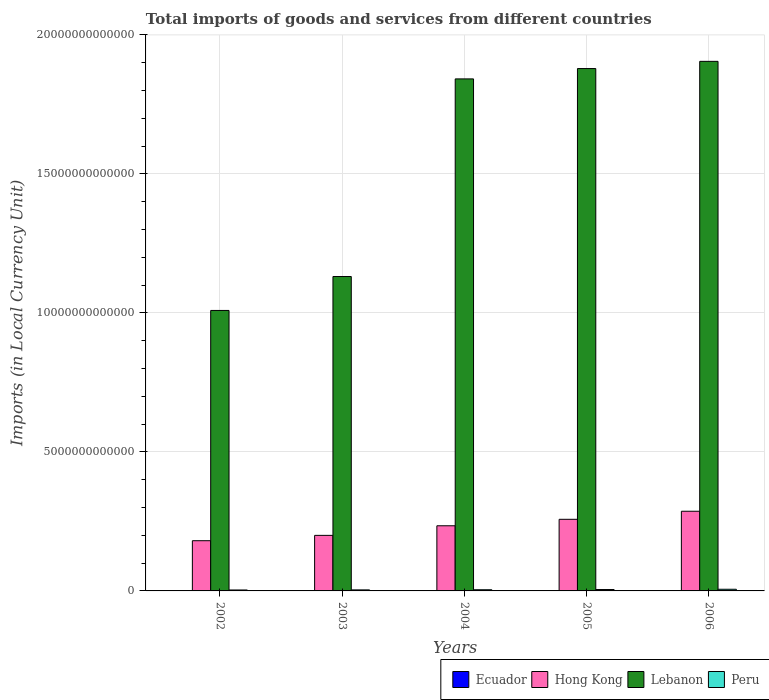Are the number of bars per tick equal to the number of legend labels?
Offer a terse response. Yes. Are the number of bars on each tick of the X-axis equal?
Make the answer very short. Yes. How many bars are there on the 5th tick from the right?
Your answer should be compact. 4. What is the label of the 5th group of bars from the left?
Make the answer very short. 2006. What is the Amount of goods and services imports in Ecuador in 2005?
Keep it short and to the point. 1.18e+1. Across all years, what is the maximum Amount of goods and services imports in Peru?
Offer a very short reply. 6.00e+1. Across all years, what is the minimum Amount of goods and services imports in Hong Kong?
Offer a very short reply. 1.81e+12. In which year was the Amount of goods and services imports in Lebanon maximum?
Your answer should be compact. 2006. In which year was the Amount of goods and services imports in Ecuador minimum?
Offer a very short reply. 2002. What is the total Amount of goods and services imports in Ecuador in the graph?
Offer a very short reply. 5.11e+1. What is the difference between the Amount of goods and services imports in Peru in 2003 and that in 2006?
Make the answer very short. -2.28e+1. What is the difference between the Amount of goods and services imports in Hong Kong in 2005 and the Amount of goods and services imports in Ecuador in 2006?
Your answer should be compact. 2.56e+12. What is the average Amount of goods and services imports in Peru per year?
Offer a terse response. 4.48e+1. In the year 2006, what is the difference between the Amount of goods and services imports in Peru and Amount of goods and services imports in Lebanon?
Provide a short and direct response. -1.90e+13. In how many years, is the Amount of goods and services imports in Lebanon greater than 4000000000000 LCU?
Offer a very short reply. 5. What is the ratio of the Amount of goods and services imports in Peru in 2004 to that in 2006?
Your response must be concise. 0.71. Is the Amount of goods and services imports in Ecuador in 2003 less than that in 2004?
Provide a succinct answer. Yes. Is the difference between the Amount of goods and services imports in Peru in 2004 and 2005 greater than the difference between the Amount of goods and services imports in Lebanon in 2004 and 2005?
Ensure brevity in your answer.  Yes. What is the difference between the highest and the second highest Amount of goods and services imports in Lebanon?
Offer a terse response. 2.59e+11. What is the difference between the highest and the lowest Amount of goods and services imports in Ecuador?
Your answer should be very brief. 5.79e+09. Is the sum of the Amount of goods and services imports in Hong Kong in 2004 and 2005 greater than the maximum Amount of goods and services imports in Lebanon across all years?
Offer a terse response. No. Is it the case that in every year, the sum of the Amount of goods and services imports in Peru and Amount of goods and services imports in Hong Kong is greater than the sum of Amount of goods and services imports in Lebanon and Amount of goods and services imports in Ecuador?
Keep it short and to the point. No. What does the 1st bar from the left in 2006 represents?
Your response must be concise. Ecuador. What does the 2nd bar from the right in 2002 represents?
Ensure brevity in your answer.  Lebanon. How many bars are there?
Give a very brief answer. 20. How many years are there in the graph?
Your response must be concise. 5. What is the difference between two consecutive major ticks on the Y-axis?
Ensure brevity in your answer.  5.00e+12. Are the values on the major ticks of Y-axis written in scientific E-notation?
Your response must be concise. No. Does the graph contain grids?
Make the answer very short. Yes. Where does the legend appear in the graph?
Make the answer very short. Bottom right. What is the title of the graph?
Ensure brevity in your answer.  Total imports of goods and services from different countries. Does "Northern Mariana Islands" appear as one of the legend labels in the graph?
Offer a very short reply. No. What is the label or title of the Y-axis?
Give a very brief answer. Imports (in Local Currency Unit). What is the Imports (in Local Currency Unit) in Ecuador in 2002?
Offer a very short reply. 7.96e+09. What is the Imports (in Local Currency Unit) of Hong Kong in 2002?
Provide a succinct answer. 1.81e+12. What is the Imports (in Local Currency Unit) in Lebanon in 2002?
Offer a terse response. 1.01e+13. What is the Imports (in Local Currency Unit) of Peru in 2002?
Keep it short and to the point. 3.40e+1. What is the Imports (in Local Currency Unit) of Ecuador in 2003?
Provide a short and direct response. 7.99e+09. What is the Imports (in Local Currency Unit) of Hong Kong in 2003?
Your answer should be very brief. 2.00e+12. What is the Imports (in Local Currency Unit) in Lebanon in 2003?
Make the answer very short. 1.13e+13. What is the Imports (in Local Currency Unit) of Peru in 2003?
Keep it short and to the point. 3.73e+1. What is the Imports (in Local Currency Unit) of Ecuador in 2004?
Provide a short and direct response. 9.55e+09. What is the Imports (in Local Currency Unit) of Hong Kong in 2004?
Ensure brevity in your answer.  2.34e+12. What is the Imports (in Local Currency Unit) in Lebanon in 2004?
Your response must be concise. 1.84e+13. What is the Imports (in Local Currency Unit) in Peru in 2004?
Your answer should be very brief. 4.24e+1. What is the Imports (in Local Currency Unit) in Ecuador in 2005?
Your response must be concise. 1.18e+1. What is the Imports (in Local Currency Unit) in Hong Kong in 2005?
Offer a terse response. 2.58e+12. What is the Imports (in Local Currency Unit) in Lebanon in 2005?
Make the answer very short. 1.88e+13. What is the Imports (in Local Currency Unit) of Peru in 2005?
Offer a terse response. 5.02e+1. What is the Imports (in Local Currency Unit) in Ecuador in 2006?
Provide a short and direct response. 1.37e+1. What is the Imports (in Local Currency Unit) of Hong Kong in 2006?
Make the answer very short. 2.87e+12. What is the Imports (in Local Currency Unit) in Lebanon in 2006?
Provide a short and direct response. 1.90e+13. What is the Imports (in Local Currency Unit) in Peru in 2006?
Provide a succinct answer. 6.00e+1. Across all years, what is the maximum Imports (in Local Currency Unit) of Ecuador?
Provide a succinct answer. 1.37e+1. Across all years, what is the maximum Imports (in Local Currency Unit) of Hong Kong?
Your answer should be compact. 2.87e+12. Across all years, what is the maximum Imports (in Local Currency Unit) in Lebanon?
Give a very brief answer. 1.90e+13. Across all years, what is the maximum Imports (in Local Currency Unit) in Peru?
Give a very brief answer. 6.00e+1. Across all years, what is the minimum Imports (in Local Currency Unit) in Ecuador?
Provide a short and direct response. 7.96e+09. Across all years, what is the minimum Imports (in Local Currency Unit) in Hong Kong?
Provide a short and direct response. 1.81e+12. Across all years, what is the minimum Imports (in Local Currency Unit) of Lebanon?
Your answer should be very brief. 1.01e+13. Across all years, what is the minimum Imports (in Local Currency Unit) of Peru?
Offer a very short reply. 3.40e+1. What is the total Imports (in Local Currency Unit) in Ecuador in the graph?
Your answer should be compact. 5.11e+1. What is the total Imports (in Local Currency Unit) of Hong Kong in the graph?
Offer a very short reply. 1.16e+13. What is the total Imports (in Local Currency Unit) of Lebanon in the graph?
Give a very brief answer. 7.77e+13. What is the total Imports (in Local Currency Unit) of Peru in the graph?
Provide a succinct answer. 2.24e+11. What is the difference between the Imports (in Local Currency Unit) of Ecuador in 2002 and that in 2003?
Provide a succinct answer. -3.19e+07. What is the difference between the Imports (in Local Currency Unit) of Hong Kong in 2002 and that in 2003?
Give a very brief answer. -1.93e+11. What is the difference between the Imports (in Local Currency Unit) of Lebanon in 2002 and that in 2003?
Provide a short and direct response. -1.22e+12. What is the difference between the Imports (in Local Currency Unit) of Peru in 2002 and that in 2003?
Provide a succinct answer. -3.24e+09. What is the difference between the Imports (in Local Currency Unit) in Ecuador in 2002 and that in 2004?
Ensure brevity in your answer.  -1.59e+09. What is the difference between the Imports (in Local Currency Unit) in Hong Kong in 2002 and that in 2004?
Ensure brevity in your answer.  -5.37e+11. What is the difference between the Imports (in Local Currency Unit) of Lebanon in 2002 and that in 2004?
Offer a terse response. -8.33e+12. What is the difference between the Imports (in Local Currency Unit) of Peru in 2002 and that in 2004?
Make the answer very short. -8.37e+09. What is the difference between the Imports (in Local Currency Unit) in Ecuador in 2002 and that in 2005?
Provide a short and direct response. -3.86e+09. What is the difference between the Imports (in Local Currency Unit) of Hong Kong in 2002 and that in 2005?
Your response must be concise. -7.70e+11. What is the difference between the Imports (in Local Currency Unit) of Lebanon in 2002 and that in 2005?
Your answer should be compact. -8.70e+12. What is the difference between the Imports (in Local Currency Unit) in Peru in 2002 and that in 2005?
Ensure brevity in your answer.  -1.61e+1. What is the difference between the Imports (in Local Currency Unit) of Ecuador in 2002 and that in 2006?
Offer a very short reply. -5.79e+09. What is the difference between the Imports (in Local Currency Unit) of Hong Kong in 2002 and that in 2006?
Ensure brevity in your answer.  -1.06e+12. What is the difference between the Imports (in Local Currency Unit) of Lebanon in 2002 and that in 2006?
Make the answer very short. -8.96e+12. What is the difference between the Imports (in Local Currency Unit) of Peru in 2002 and that in 2006?
Ensure brevity in your answer.  -2.60e+1. What is the difference between the Imports (in Local Currency Unit) in Ecuador in 2003 and that in 2004?
Offer a very short reply. -1.56e+09. What is the difference between the Imports (in Local Currency Unit) in Hong Kong in 2003 and that in 2004?
Offer a terse response. -3.45e+11. What is the difference between the Imports (in Local Currency Unit) of Lebanon in 2003 and that in 2004?
Your response must be concise. -7.11e+12. What is the difference between the Imports (in Local Currency Unit) in Peru in 2003 and that in 2004?
Your answer should be very brief. -5.13e+09. What is the difference between the Imports (in Local Currency Unit) of Ecuador in 2003 and that in 2005?
Ensure brevity in your answer.  -3.83e+09. What is the difference between the Imports (in Local Currency Unit) of Hong Kong in 2003 and that in 2005?
Keep it short and to the point. -5.78e+11. What is the difference between the Imports (in Local Currency Unit) in Lebanon in 2003 and that in 2005?
Provide a short and direct response. -7.48e+12. What is the difference between the Imports (in Local Currency Unit) in Peru in 2003 and that in 2005?
Your answer should be compact. -1.29e+1. What is the difference between the Imports (in Local Currency Unit) of Ecuador in 2003 and that in 2006?
Your answer should be compact. -5.76e+09. What is the difference between the Imports (in Local Currency Unit) in Hong Kong in 2003 and that in 2006?
Keep it short and to the point. -8.67e+11. What is the difference between the Imports (in Local Currency Unit) of Lebanon in 2003 and that in 2006?
Your response must be concise. -7.74e+12. What is the difference between the Imports (in Local Currency Unit) in Peru in 2003 and that in 2006?
Offer a terse response. -2.28e+1. What is the difference between the Imports (in Local Currency Unit) of Ecuador in 2004 and that in 2005?
Make the answer very short. -2.27e+09. What is the difference between the Imports (in Local Currency Unit) in Hong Kong in 2004 and that in 2005?
Your answer should be very brief. -2.33e+11. What is the difference between the Imports (in Local Currency Unit) in Lebanon in 2004 and that in 2005?
Provide a short and direct response. -3.72e+11. What is the difference between the Imports (in Local Currency Unit) in Peru in 2004 and that in 2005?
Provide a succinct answer. -7.77e+09. What is the difference between the Imports (in Local Currency Unit) of Ecuador in 2004 and that in 2006?
Ensure brevity in your answer.  -4.19e+09. What is the difference between the Imports (in Local Currency Unit) in Hong Kong in 2004 and that in 2006?
Offer a terse response. -5.23e+11. What is the difference between the Imports (in Local Currency Unit) of Lebanon in 2004 and that in 2006?
Offer a terse response. -6.31e+11. What is the difference between the Imports (in Local Currency Unit) in Peru in 2004 and that in 2006?
Ensure brevity in your answer.  -1.76e+1. What is the difference between the Imports (in Local Currency Unit) in Ecuador in 2005 and that in 2006?
Keep it short and to the point. -1.93e+09. What is the difference between the Imports (in Local Currency Unit) in Hong Kong in 2005 and that in 2006?
Give a very brief answer. -2.90e+11. What is the difference between the Imports (in Local Currency Unit) in Lebanon in 2005 and that in 2006?
Provide a succinct answer. -2.59e+11. What is the difference between the Imports (in Local Currency Unit) of Peru in 2005 and that in 2006?
Your answer should be compact. -9.86e+09. What is the difference between the Imports (in Local Currency Unit) of Ecuador in 2002 and the Imports (in Local Currency Unit) of Hong Kong in 2003?
Your answer should be very brief. -1.99e+12. What is the difference between the Imports (in Local Currency Unit) in Ecuador in 2002 and the Imports (in Local Currency Unit) in Lebanon in 2003?
Offer a terse response. -1.13e+13. What is the difference between the Imports (in Local Currency Unit) of Ecuador in 2002 and the Imports (in Local Currency Unit) of Peru in 2003?
Provide a succinct answer. -2.93e+1. What is the difference between the Imports (in Local Currency Unit) in Hong Kong in 2002 and the Imports (in Local Currency Unit) in Lebanon in 2003?
Provide a short and direct response. -9.50e+12. What is the difference between the Imports (in Local Currency Unit) in Hong Kong in 2002 and the Imports (in Local Currency Unit) in Peru in 2003?
Offer a terse response. 1.77e+12. What is the difference between the Imports (in Local Currency Unit) of Lebanon in 2002 and the Imports (in Local Currency Unit) of Peru in 2003?
Give a very brief answer. 1.01e+13. What is the difference between the Imports (in Local Currency Unit) of Ecuador in 2002 and the Imports (in Local Currency Unit) of Hong Kong in 2004?
Give a very brief answer. -2.34e+12. What is the difference between the Imports (in Local Currency Unit) of Ecuador in 2002 and the Imports (in Local Currency Unit) of Lebanon in 2004?
Your response must be concise. -1.84e+13. What is the difference between the Imports (in Local Currency Unit) in Ecuador in 2002 and the Imports (in Local Currency Unit) in Peru in 2004?
Your response must be concise. -3.44e+1. What is the difference between the Imports (in Local Currency Unit) of Hong Kong in 2002 and the Imports (in Local Currency Unit) of Lebanon in 2004?
Provide a succinct answer. -1.66e+13. What is the difference between the Imports (in Local Currency Unit) of Hong Kong in 2002 and the Imports (in Local Currency Unit) of Peru in 2004?
Your answer should be compact. 1.76e+12. What is the difference between the Imports (in Local Currency Unit) of Lebanon in 2002 and the Imports (in Local Currency Unit) of Peru in 2004?
Provide a short and direct response. 1.00e+13. What is the difference between the Imports (in Local Currency Unit) in Ecuador in 2002 and the Imports (in Local Currency Unit) in Hong Kong in 2005?
Provide a succinct answer. -2.57e+12. What is the difference between the Imports (in Local Currency Unit) of Ecuador in 2002 and the Imports (in Local Currency Unit) of Lebanon in 2005?
Offer a very short reply. -1.88e+13. What is the difference between the Imports (in Local Currency Unit) of Ecuador in 2002 and the Imports (in Local Currency Unit) of Peru in 2005?
Offer a terse response. -4.22e+1. What is the difference between the Imports (in Local Currency Unit) in Hong Kong in 2002 and the Imports (in Local Currency Unit) in Lebanon in 2005?
Your answer should be compact. -1.70e+13. What is the difference between the Imports (in Local Currency Unit) of Hong Kong in 2002 and the Imports (in Local Currency Unit) of Peru in 2005?
Offer a terse response. 1.76e+12. What is the difference between the Imports (in Local Currency Unit) in Lebanon in 2002 and the Imports (in Local Currency Unit) in Peru in 2005?
Provide a succinct answer. 1.00e+13. What is the difference between the Imports (in Local Currency Unit) of Ecuador in 2002 and the Imports (in Local Currency Unit) of Hong Kong in 2006?
Offer a very short reply. -2.86e+12. What is the difference between the Imports (in Local Currency Unit) of Ecuador in 2002 and the Imports (in Local Currency Unit) of Lebanon in 2006?
Your response must be concise. -1.90e+13. What is the difference between the Imports (in Local Currency Unit) in Ecuador in 2002 and the Imports (in Local Currency Unit) in Peru in 2006?
Give a very brief answer. -5.21e+1. What is the difference between the Imports (in Local Currency Unit) in Hong Kong in 2002 and the Imports (in Local Currency Unit) in Lebanon in 2006?
Make the answer very short. -1.72e+13. What is the difference between the Imports (in Local Currency Unit) of Hong Kong in 2002 and the Imports (in Local Currency Unit) of Peru in 2006?
Provide a short and direct response. 1.75e+12. What is the difference between the Imports (in Local Currency Unit) of Lebanon in 2002 and the Imports (in Local Currency Unit) of Peru in 2006?
Make the answer very short. 1.00e+13. What is the difference between the Imports (in Local Currency Unit) of Ecuador in 2003 and the Imports (in Local Currency Unit) of Hong Kong in 2004?
Your answer should be compact. -2.34e+12. What is the difference between the Imports (in Local Currency Unit) of Ecuador in 2003 and the Imports (in Local Currency Unit) of Lebanon in 2004?
Offer a very short reply. -1.84e+13. What is the difference between the Imports (in Local Currency Unit) in Ecuador in 2003 and the Imports (in Local Currency Unit) in Peru in 2004?
Your answer should be very brief. -3.44e+1. What is the difference between the Imports (in Local Currency Unit) of Hong Kong in 2003 and the Imports (in Local Currency Unit) of Lebanon in 2004?
Ensure brevity in your answer.  -1.64e+13. What is the difference between the Imports (in Local Currency Unit) in Hong Kong in 2003 and the Imports (in Local Currency Unit) in Peru in 2004?
Make the answer very short. 1.96e+12. What is the difference between the Imports (in Local Currency Unit) in Lebanon in 2003 and the Imports (in Local Currency Unit) in Peru in 2004?
Give a very brief answer. 1.13e+13. What is the difference between the Imports (in Local Currency Unit) in Ecuador in 2003 and the Imports (in Local Currency Unit) in Hong Kong in 2005?
Give a very brief answer. -2.57e+12. What is the difference between the Imports (in Local Currency Unit) in Ecuador in 2003 and the Imports (in Local Currency Unit) in Lebanon in 2005?
Your answer should be compact. -1.88e+13. What is the difference between the Imports (in Local Currency Unit) in Ecuador in 2003 and the Imports (in Local Currency Unit) in Peru in 2005?
Your answer should be very brief. -4.22e+1. What is the difference between the Imports (in Local Currency Unit) of Hong Kong in 2003 and the Imports (in Local Currency Unit) of Lebanon in 2005?
Your response must be concise. -1.68e+13. What is the difference between the Imports (in Local Currency Unit) of Hong Kong in 2003 and the Imports (in Local Currency Unit) of Peru in 2005?
Make the answer very short. 1.95e+12. What is the difference between the Imports (in Local Currency Unit) in Lebanon in 2003 and the Imports (in Local Currency Unit) in Peru in 2005?
Your response must be concise. 1.13e+13. What is the difference between the Imports (in Local Currency Unit) of Ecuador in 2003 and the Imports (in Local Currency Unit) of Hong Kong in 2006?
Give a very brief answer. -2.86e+12. What is the difference between the Imports (in Local Currency Unit) of Ecuador in 2003 and the Imports (in Local Currency Unit) of Lebanon in 2006?
Provide a succinct answer. -1.90e+13. What is the difference between the Imports (in Local Currency Unit) of Ecuador in 2003 and the Imports (in Local Currency Unit) of Peru in 2006?
Offer a terse response. -5.20e+1. What is the difference between the Imports (in Local Currency Unit) in Hong Kong in 2003 and the Imports (in Local Currency Unit) in Lebanon in 2006?
Offer a terse response. -1.71e+13. What is the difference between the Imports (in Local Currency Unit) in Hong Kong in 2003 and the Imports (in Local Currency Unit) in Peru in 2006?
Your answer should be compact. 1.94e+12. What is the difference between the Imports (in Local Currency Unit) in Lebanon in 2003 and the Imports (in Local Currency Unit) in Peru in 2006?
Your answer should be very brief. 1.12e+13. What is the difference between the Imports (in Local Currency Unit) in Ecuador in 2004 and the Imports (in Local Currency Unit) in Hong Kong in 2005?
Provide a short and direct response. -2.57e+12. What is the difference between the Imports (in Local Currency Unit) in Ecuador in 2004 and the Imports (in Local Currency Unit) in Lebanon in 2005?
Give a very brief answer. -1.88e+13. What is the difference between the Imports (in Local Currency Unit) in Ecuador in 2004 and the Imports (in Local Currency Unit) in Peru in 2005?
Keep it short and to the point. -4.06e+1. What is the difference between the Imports (in Local Currency Unit) of Hong Kong in 2004 and the Imports (in Local Currency Unit) of Lebanon in 2005?
Offer a very short reply. -1.64e+13. What is the difference between the Imports (in Local Currency Unit) in Hong Kong in 2004 and the Imports (in Local Currency Unit) in Peru in 2005?
Keep it short and to the point. 2.29e+12. What is the difference between the Imports (in Local Currency Unit) of Lebanon in 2004 and the Imports (in Local Currency Unit) of Peru in 2005?
Provide a succinct answer. 1.84e+13. What is the difference between the Imports (in Local Currency Unit) in Ecuador in 2004 and the Imports (in Local Currency Unit) in Hong Kong in 2006?
Give a very brief answer. -2.86e+12. What is the difference between the Imports (in Local Currency Unit) of Ecuador in 2004 and the Imports (in Local Currency Unit) of Lebanon in 2006?
Give a very brief answer. -1.90e+13. What is the difference between the Imports (in Local Currency Unit) of Ecuador in 2004 and the Imports (in Local Currency Unit) of Peru in 2006?
Your answer should be compact. -5.05e+1. What is the difference between the Imports (in Local Currency Unit) in Hong Kong in 2004 and the Imports (in Local Currency Unit) in Lebanon in 2006?
Make the answer very short. -1.67e+13. What is the difference between the Imports (in Local Currency Unit) of Hong Kong in 2004 and the Imports (in Local Currency Unit) of Peru in 2006?
Your answer should be compact. 2.28e+12. What is the difference between the Imports (in Local Currency Unit) in Lebanon in 2004 and the Imports (in Local Currency Unit) in Peru in 2006?
Your answer should be compact. 1.84e+13. What is the difference between the Imports (in Local Currency Unit) of Ecuador in 2005 and the Imports (in Local Currency Unit) of Hong Kong in 2006?
Your answer should be very brief. -2.85e+12. What is the difference between the Imports (in Local Currency Unit) of Ecuador in 2005 and the Imports (in Local Currency Unit) of Lebanon in 2006?
Offer a very short reply. -1.90e+13. What is the difference between the Imports (in Local Currency Unit) in Ecuador in 2005 and the Imports (in Local Currency Unit) in Peru in 2006?
Your answer should be very brief. -4.82e+1. What is the difference between the Imports (in Local Currency Unit) of Hong Kong in 2005 and the Imports (in Local Currency Unit) of Lebanon in 2006?
Keep it short and to the point. -1.65e+13. What is the difference between the Imports (in Local Currency Unit) in Hong Kong in 2005 and the Imports (in Local Currency Unit) in Peru in 2006?
Offer a very short reply. 2.52e+12. What is the difference between the Imports (in Local Currency Unit) of Lebanon in 2005 and the Imports (in Local Currency Unit) of Peru in 2006?
Your answer should be very brief. 1.87e+13. What is the average Imports (in Local Currency Unit) in Ecuador per year?
Make the answer very short. 1.02e+1. What is the average Imports (in Local Currency Unit) in Hong Kong per year?
Provide a succinct answer. 2.32e+12. What is the average Imports (in Local Currency Unit) in Lebanon per year?
Offer a very short reply. 1.55e+13. What is the average Imports (in Local Currency Unit) of Peru per year?
Offer a terse response. 4.48e+1. In the year 2002, what is the difference between the Imports (in Local Currency Unit) of Ecuador and Imports (in Local Currency Unit) of Hong Kong?
Make the answer very short. -1.80e+12. In the year 2002, what is the difference between the Imports (in Local Currency Unit) of Ecuador and Imports (in Local Currency Unit) of Lebanon?
Provide a succinct answer. -1.01e+13. In the year 2002, what is the difference between the Imports (in Local Currency Unit) of Ecuador and Imports (in Local Currency Unit) of Peru?
Give a very brief answer. -2.60e+1. In the year 2002, what is the difference between the Imports (in Local Currency Unit) in Hong Kong and Imports (in Local Currency Unit) in Lebanon?
Provide a succinct answer. -8.28e+12. In the year 2002, what is the difference between the Imports (in Local Currency Unit) in Hong Kong and Imports (in Local Currency Unit) in Peru?
Offer a terse response. 1.77e+12. In the year 2002, what is the difference between the Imports (in Local Currency Unit) in Lebanon and Imports (in Local Currency Unit) in Peru?
Your answer should be compact. 1.01e+13. In the year 2003, what is the difference between the Imports (in Local Currency Unit) of Ecuador and Imports (in Local Currency Unit) of Hong Kong?
Make the answer very short. -1.99e+12. In the year 2003, what is the difference between the Imports (in Local Currency Unit) of Ecuador and Imports (in Local Currency Unit) of Lebanon?
Your answer should be compact. -1.13e+13. In the year 2003, what is the difference between the Imports (in Local Currency Unit) of Ecuador and Imports (in Local Currency Unit) of Peru?
Make the answer very short. -2.93e+1. In the year 2003, what is the difference between the Imports (in Local Currency Unit) in Hong Kong and Imports (in Local Currency Unit) in Lebanon?
Your response must be concise. -9.31e+12. In the year 2003, what is the difference between the Imports (in Local Currency Unit) in Hong Kong and Imports (in Local Currency Unit) in Peru?
Make the answer very short. 1.96e+12. In the year 2003, what is the difference between the Imports (in Local Currency Unit) of Lebanon and Imports (in Local Currency Unit) of Peru?
Provide a short and direct response. 1.13e+13. In the year 2004, what is the difference between the Imports (in Local Currency Unit) in Ecuador and Imports (in Local Currency Unit) in Hong Kong?
Offer a terse response. -2.33e+12. In the year 2004, what is the difference between the Imports (in Local Currency Unit) of Ecuador and Imports (in Local Currency Unit) of Lebanon?
Provide a succinct answer. -1.84e+13. In the year 2004, what is the difference between the Imports (in Local Currency Unit) in Ecuador and Imports (in Local Currency Unit) in Peru?
Offer a terse response. -3.28e+1. In the year 2004, what is the difference between the Imports (in Local Currency Unit) in Hong Kong and Imports (in Local Currency Unit) in Lebanon?
Provide a short and direct response. -1.61e+13. In the year 2004, what is the difference between the Imports (in Local Currency Unit) of Hong Kong and Imports (in Local Currency Unit) of Peru?
Offer a very short reply. 2.30e+12. In the year 2004, what is the difference between the Imports (in Local Currency Unit) in Lebanon and Imports (in Local Currency Unit) in Peru?
Provide a succinct answer. 1.84e+13. In the year 2005, what is the difference between the Imports (in Local Currency Unit) in Ecuador and Imports (in Local Currency Unit) in Hong Kong?
Give a very brief answer. -2.56e+12. In the year 2005, what is the difference between the Imports (in Local Currency Unit) of Ecuador and Imports (in Local Currency Unit) of Lebanon?
Ensure brevity in your answer.  -1.88e+13. In the year 2005, what is the difference between the Imports (in Local Currency Unit) in Ecuador and Imports (in Local Currency Unit) in Peru?
Offer a terse response. -3.83e+1. In the year 2005, what is the difference between the Imports (in Local Currency Unit) in Hong Kong and Imports (in Local Currency Unit) in Lebanon?
Your response must be concise. -1.62e+13. In the year 2005, what is the difference between the Imports (in Local Currency Unit) in Hong Kong and Imports (in Local Currency Unit) in Peru?
Give a very brief answer. 2.53e+12. In the year 2005, what is the difference between the Imports (in Local Currency Unit) in Lebanon and Imports (in Local Currency Unit) in Peru?
Offer a very short reply. 1.87e+13. In the year 2006, what is the difference between the Imports (in Local Currency Unit) in Ecuador and Imports (in Local Currency Unit) in Hong Kong?
Ensure brevity in your answer.  -2.85e+12. In the year 2006, what is the difference between the Imports (in Local Currency Unit) of Ecuador and Imports (in Local Currency Unit) of Lebanon?
Make the answer very short. -1.90e+13. In the year 2006, what is the difference between the Imports (in Local Currency Unit) of Ecuador and Imports (in Local Currency Unit) of Peru?
Provide a succinct answer. -4.63e+1. In the year 2006, what is the difference between the Imports (in Local Currency Unit) in Hong Kong and Imports (in Local Currency Unit) in Lebanon?
Offer a terse response. -1.62e+13. In the year 2006, what is the difference between the Imports (in Local Currency Unit) in Hong Kong and Imports (in Local Currency Unit) in Peru?
Keep it short and to the point. 2.81e+12. In the year 2006, what is the difference between the Imports (in Local Currency Unit) of Lebanon and Imports (in Local Currency Unit) of Peru?
Ensure brevity in your answer.  1.90e+13. What is the ratio of the Imports (in Local Currency Unit) in Ecuador in 2002 to that in 2003?
Ensure brevity in your answer.  1. What is the ratio of the Imports (in Local Currency Unit) in Hong Kong in 2002 to that in 2003?
Keep it short and to the point. 0.9. What is the ratio of the Imports (in Local Currency Unit) in Lebanon in 2002 to that in 2003?
Give a very brief answer. 0.89. What is the ratio of the Imports (in Local Currency Unit) in Peru in 2002 to that in 2003?
Your answer should be compact. 0.91. What is the ratio of the Imports (in Local Currency Unit) of Ecuador in 2002 to that in 2004?
Make the answer very short. 0.83. What is the ratio of the Imports (in Local Currency Unit) in Hong Kong in 2002 to that in 2004?
Keep it short and to the point. 0.77. What is the ratio of the Imports (in Local Currency Unit) in Lebanon in 2002 to that in 2004?
Your answer should be very brief. 0.55. What is the ratio of the Imports (in Local Currency Unit) in Peru in 2002 to that in 2004?
Keep it short and to the point. 0.8. What is the ratio of the Imports (in Local Currency Unit) of Ecuador in 2002 to that in 2005?
Offer a terse response. 0.67. What is the ratio of the Imports (in Local Currency Unit) in Hong Kong in 2002 to that in 2005?
Give a very brief answer. 0.7. What is the ratio of the Imports (in Local Currency Unit) of Lebanon in 2002 to that in 2005?
Offer a terse response. 0.54. What is the ratio of the Imports (in Local Currency Unit) in Peru in 2002 to that in 2005?
Your response must be concise. 0.68. What is the ratio of the Imports (in Local Currency Unit) in Ecuador in 2002 to that in 2006?
Ensure brevity in your answer.  0.58. What is the ratio of the Imports (in Local Currency Unit) in Hong Kong in 2002 to that in 2006?
Your answer should be very brief. 0.63. What is the ratio of the Imports (in Local Currency Unit) of Lebanon in 2002 to that in 2006?
Offer a terse response. 0.53. What is the ratio of the Imports (in Local Currency Unit) of Peru in 2002 to that in 2006?
Keep it short and to the point. 0.57. What is the ratio of the Imports (in Local Currency Unit) of Ecuador in 2003 to that in 2004?
Your answer should be very brief. 0.84. What is the ratio of the Imports (in Local Currency Unit) of Hong Kong in 2003 to that in 2004?
Make the answer very short. 0.85. What is the ratio of the Imports (in Local Currency Unit) in Lebanon in 2003 to that in 2004?
Offer a very short reply. 0.61. What is the ratio of the Imports (in Local Currency Unit) of Peru in 2003 to that in 2004?
Offer a terse response. 0.88. What is the ratio of the Imports (in Local Currency Unit) in Ecuador in 2003 to that in 2005?
Provide a succinct answer. 0.68. What is the ratio of the Imports (in Local Currency Unit) in Hong Kong in 2003 to that in 2005?
Provide a short and direct response. 0.78. What is the ratio of the Imports (in Local Currency Unit) in Lebanon in 2003 to that in 2005?
Your answer should be compact. 0.6. What is the ratio of the Imports (in Local Currency Unit) of Peru in 2003 to that in 2005?
Ensure brevity in your answer.  0.74. What is the ratio of the Imports (in Local Currency Unit) in Ecuador in 2003 to that in 2006?
Your answer should be compact. 0.58. What is the ratio of the Imports (in Local Currency Unit) of Hong Kong in 2003 to that in 2006?
Ensure brevity in your answer.  0.7. What is the ratio of the Imports (in Local Currency Unit) in Lebanon in 2003 to that in 2006?
Provide a short and direct response. 0.59. What is the ratio of the Imports (in Local Currency Unit) in Peru in 2003 to that in 2006?
Give a very brief answer. 0.62. What is the ratio of the Imports (in Local Currency Unit) in Ecuador in 2004 to that in 2005?
Offer a very short reply. 0.81. What is the ratio of the Imports (in Local Currency Unit) of Hong Kong in 2004 to that in 2005?
Your response must be concise. 0.91. What is the ratio of the Imports (in Local Currency Unit) of Lebanon in 2004 to that in 2005?
Your answer should be compact. 0.98. What is the ratio of the Imports (in Local Currency Unit) of Peru in 2004 to that in 2005?
Your answer should be very brief. 0.85. What is the ratio of the Imports (in Local Currency Unit) in Ecuador in 2004 to that in 2006?
Your answer should be compact. 0.69. What is the ratio of the Imports (in Local Currency Unit) of Hong Kong in 2004 to that in 2006?
Keep it short and to the point. 0.82. What is the ratio of the Imports (in Local Currency Unit) in Lebanon in 2004 to that in 2006?
Your response must be concise. 0.97. What is the ratio of the Imports (in Local Currency Unit) of Peru in 2004 to that in 2006?
Offer a very short reply. 0.71. What is the ratio of the Imports (in Local Currency Unit) in Ecuador in 2005 to that in 2006?
Offer a terse response. 0.86. What is the ratio of the Imports (in Local Currency Unit) in Hong Kong in 2005 to that in 2006?
Offer a very short reply. 0.9. What is the ratio of the Imports (in Local Currency Unit) of Lebanon in 2005 to that in 2006?
Provide a succinct answer. 0.99. What is the ratio of the Imports (in Local Currency Unit) in Peru in 2005 to that in 2006?
Your answer should be compact. 0.84. What is the difference between the highest and the second highest Imports (in Local Currency Unit) in Ecuador?
Keep it short and to the point. 1.93e+09. What is the difference between the highest and the second highest Imports (in Local Currency Unit) of Hong Kong?
Your answer should be compact. 2.90e+11. What is the difference between the highest and the second highest Imports (in Local Currency Unit) in Lebanon?
Ensure brevity in your answer.  2.59e+11. What is the difference between the highest and the second highest Imports (in Local Currency Unit) of Peru?
Your answer should be compact. 9.86e+09. What is the difference between the highest and the lowest Imports (in Local Currency Unit) in Ecuador?
Offer a very short reply. 5.79e+09. What is the difference between the highest and the lowest Imports (in Local Currency Unit) of Hong Kong?
Your answer should be very brief. 1.06e+12. What is the difference between the highest and the lowest Imports (in Local Currency Unit) of Lebanon?
Offer a terse response. 8.96e+12. What is the difference between the highest and the lowest Imports (in Local Currency Unit) of Peru?
Your response must be concise. 2.60e+1. 